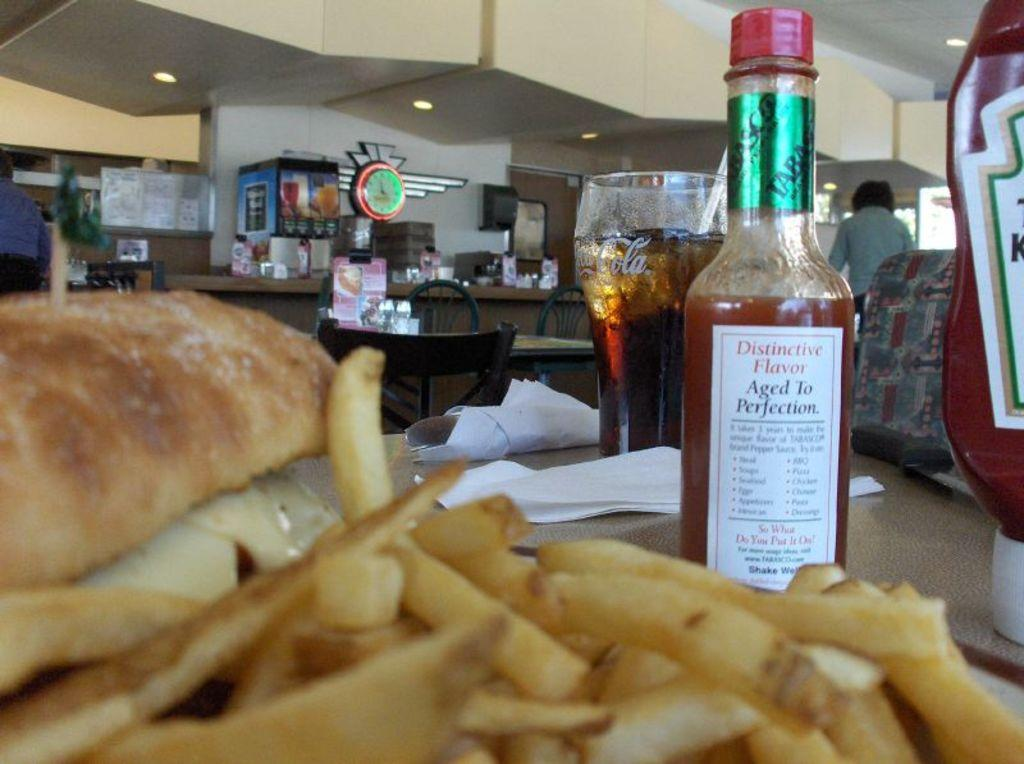What type of container is present in the image? There is a sauce bottle in the image. What type of food can be seen in the image? There are french fries in the image. What type of drinking vessel is present in the image? There is a glass in the image. What type of surface is visible in the image? There are objects on the dining table in the image. What type of background is visible in the image? There is a wall visible in the image. How many spiders are crawling on the wall in the image? There are no spiders visible in the image; only a wall is present. What type of knot is tied on the tablecloth in the image? There is no tablecloth or knot present in the image. 